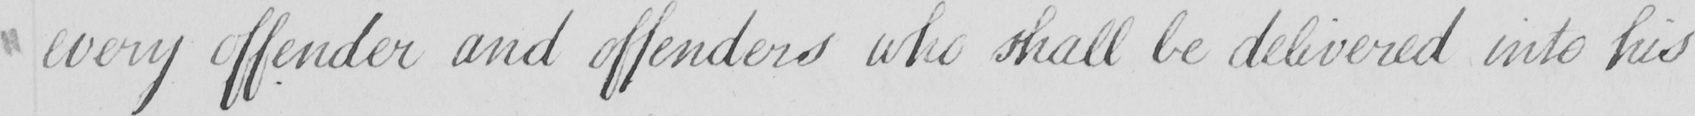Please provide the text content of this handwritten line. every offender and offenders who shall be delivered into his 